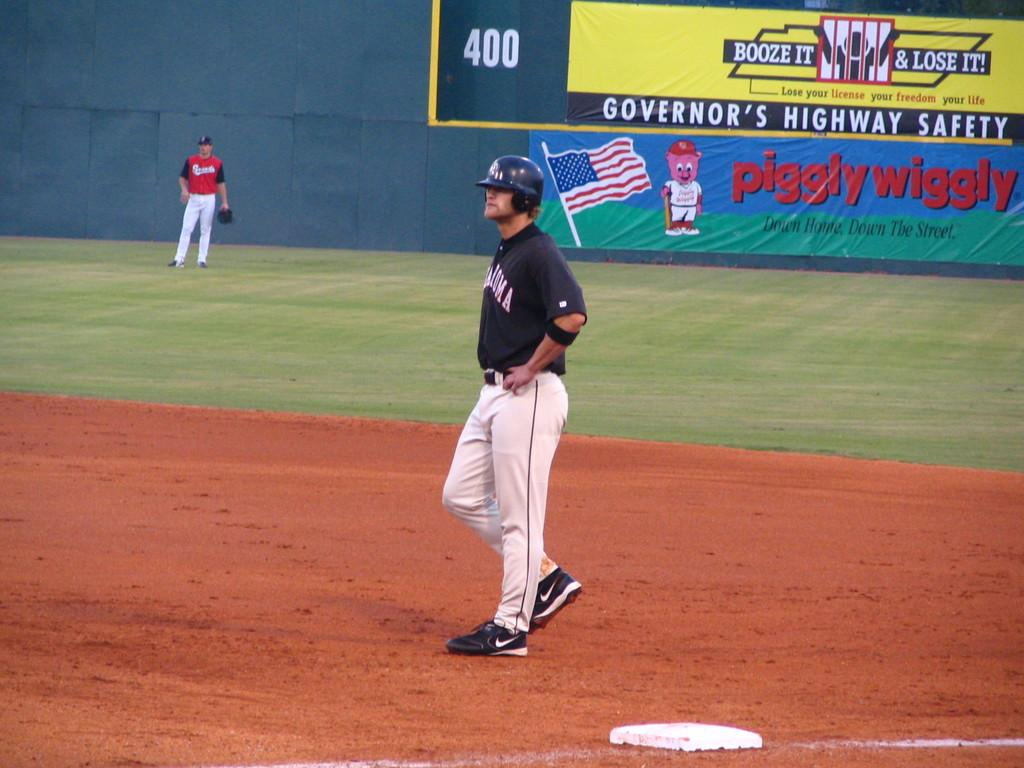<image>
Give a short and clear explanation of the subsequent image. a player on the baseball field with a piggly wiggly ad i the outfield 